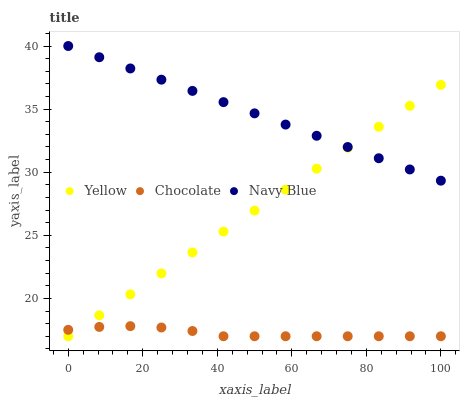Does Chocolate have the minimum area under the curve?
Answer yes or no. Yes. Does Navy Blue have the maximum area under the curve?
Answer yes or no. Yes. Does Yellow have the minimum area under the curve?
Answer yes or no. No. Does Yellow have the maximum area under the curve?
Answer yes or no. No. Is Yellow the smoothest?
Answer yes or no. Yes. Is Chocolate the roughest?
Answer yes or no. Yes. Is Chocolate the smoothest?
Answer yes or no. No. Is Yellow the roughest?
Answer yes or no. No. Does Yellow have the lowest value?
Answer yes or no. Yes. Does Navy Blue have the highest value?
Answer yes or no. Yes. Does Yellow have the highest value?
Answer yes or no. No. Is Chocolate less than Navy Blue?
Answer yes or no. Yes. Is Navy Blue greater than Chocolate?
Answer yes or no. Yes. Does Chocolate intersect Yellow?
Answer yes or no. Yes. Is Chocolate less than Yellow?
Answer yes or no. No. Is Chocolate greater than Yellow?
Answer yes or no. No. Does Chocolate intersect Navy Blue?
Answer yes or no. No. 